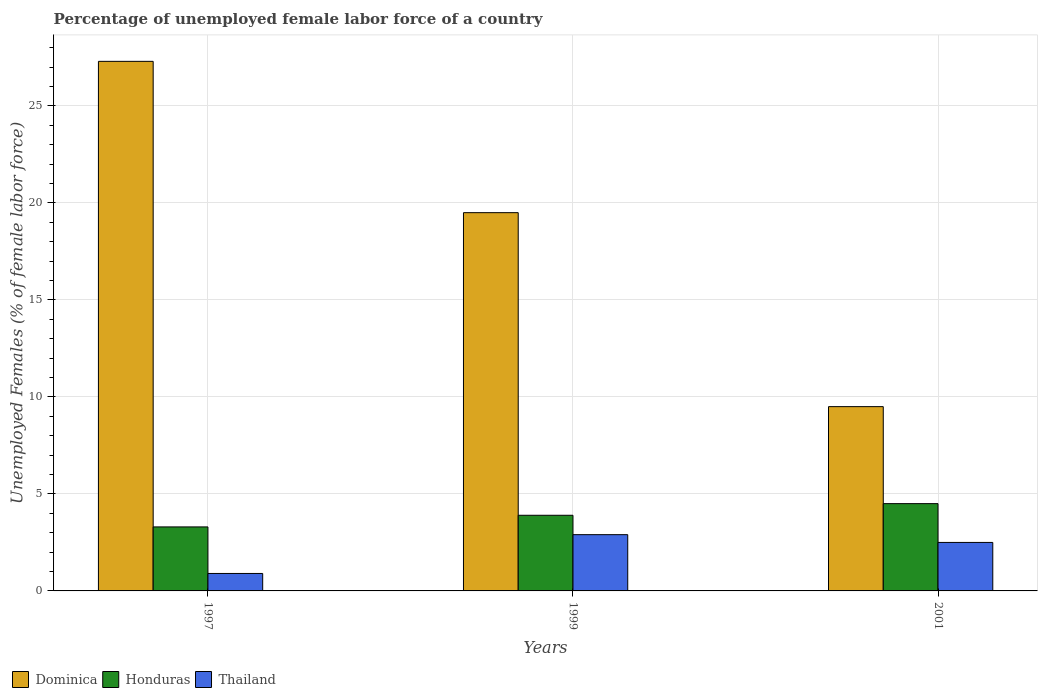How many different coloured bars are there?
Ensure brevity in your answer.  3. Are the number of bars per tick equal to the number of legend labels?
Your response must be concise. Yes. Are the number of bars on each tick of the X-axis equal?
Ensure brevity in your answer.  Yes. How many bars are there on the 3rd tick from the right?
Provide a succinct answer. 3. In how many cases, is the number of bars for a given year not equal to the number of legend labels?
Offer a very short reply. 0. What is the percentage of unemployed female labor force in Dominica in 2001?
Provide a short and direct response. 9.5. Across all years, what is the maximum percentage of unemployed female labor force in Dominica?
Your answer should be compact. 27.3. Across all years, what is the minimum percentage of unemployed female labor force in Honduras?
Your answer should be very brief. 3.3. What is the total percentage of unemployed female labor force in Thailand in the graph?
Provide a succinct answer. 6.3. What is the difference between the percentage of unemployed female labor force in Honduras in 1997 and that in 1999?
Make the answer very short. -0.6. What is the difference between the percentage of unemployed female labor force in Dominica in 1997 and the percentage of unemployed female labor force in Honduras in 2001?
Your answer should be compact. 22.8. What is the average percentage of unemployed female labor force in Dominica per year?
Provide a short and direct response. 18.77. In the year 2001, what is the difference between the percentage of unemployed female labor force in Honduras and percentage of unemployed female labor force in Dominica?
Give a very brief answer. -5. In how many years, is the percentage of unemployed female labor force in Honduras greater than 13 %?
Your response must be concise. 0. What is the ratio of the percentage of unemployed female labor force in Thailand in 1997 to that in 1999?
Keep it short and to the point. 0.31. Is the percentage of unemployed female labor force in Thailand in 1997 less than that in 2001?
Ensure brevity in your answer.  Yes. What is the difference between the highest and the second highest percentage of unemployed female labor force in Thailand?
Provide a short and direct response. 0.4. What is the difference between the highest and the lowest percentage of unemployed female labor force in Dominica?
Make the answer very short. 17.8. What does the 2nd bar from the left in 1997 represents?
Offer a terse response. Honduras. What does the 3rd bar from the right in 1999 represents?
Provide a succinct answer. Dominica. Is it the case that in every year, the sum of the percentage of unemployed female labor force in Honduras and percentage of unemployed female labor force in Thailand is greater than the percentage of unemployed female labor force in Dominica?
Provide a short and direct response. No. How many bars are there?
Give a very brief answer. 9. Are all the bars in the graph horizontal?
Make the answer very short. No. Are the values on the major ticks of Y-axis written in scientific E-notation?
Provide a short and direct response. No. Does the graph contain any zero values?
Ensure brevity in your answer.  No. Where does the legend appear in the graph?
Offer a very short reply. Bottom left. How are the legend labels stacked?
Your answer should be compact. Horizontal. What is the title of the graph?
Your answer should be compact. Percentage of unemployed female labor force of a country. Does "Colombia" appear as one of the legend labels in the graph?
Provide a short and direct response. No. What is the label or title of the X-axis?
Your answer should be very brief. Years. What is the label or title of the Y-axis?
Your response must be concise. Unemployed Females (% of female labor force). What is the Unemployed Females (% of female labor force) in Dominica in 1997?
Your response must be concise. 27.3. What is the Unemployed Females (% of female labor force) in Honduras in 1997?
Your answer should be very brief. 3.3. What is the Unemployed Females (% of female labor force) in Thailand in 1997?
Your answer should be very brief. 0.9. What is the Unemployed Females (% of female labor force) of Honduras in 1999?
Make the answer very short. 3.9. What is the Unemployed Females (% of female labor force) of Thailand in 1999?
Offer a terse response. 2.9. What is the Unemployed Females (% of female labor force) of Honduras in 2001?
Make the answer very short. 4.5. Across all years, what is the maximum Unemployed Females (% of female labor force) in Dominica?
Your answer should be compact. 27.3. Across all years, what is the maximum Unemployed Females (% of female labor force) of Honduras?
Provide a succinct answer. 4.5. Across all years, what is the maximum Unemployed Females (% of female labor force) in Thailand?
Keep it short and to the point. 2.9. Across all years, what is the minimum Unemployed Females (% of female labor force) of Dominica?
Give a very brief answer. 9.5. Across all years, what is the minimum Unemployed Females (% of female labor force) in Honduras?
Ensure brevity in your answer.  3.3. Across all years, what is the minimum Unemployed Females (% of female labor force) in Thailand?
Provide a succinct answer. 0.9. What is the total Unemployed Females (% of female labor force) of Dominica in the graph?
Your answer should be compact. 56.3. What is the difference between the Unemployed Females (% of female labor force) of Dominica in 1997 and that in 1999?
Your answer should be compact. 7.8. What is the difference between the Unemployed Females (% of female labor force) in Honduras in 1997 and that in 1999?
Offer a very short reply. -0.6. What is the difference between the Unemployed Females (% of female labor force) in Thailand in 1997 and that in 1999?
Ensure brevity in your answer.  -2. What is the difference between the Unemployed Females (% of female labor force) of Honduras in 1997 and that in 2001?
Provide a succinct answer. -1.2. What is the difference between the Unemployed Females (% of female labor force) of Thailand in 1997 and that in 2001?
Provide a short and direct response. -1.6. What is the difference between the Unemployed Females (% of female labor force) in Thailand in 1999 and that in 2001?
Your answer should be very brief. 0.4. What is the difference between the Unemployed Females (% of female labor force) in Dominica in 1997 and the Unemployed Females (% of female labor force) in Honduras in 1999?
Make the answer very short. 23.4. What is the difference between the Unemployed Females (% of female labor force) of Dominica in 1997 and the Unemployed Females (% of female labor force) of Thailand in 1999?
Offer a terse response. 24.4. What is the difference between the Unemployed Females (% of female labor force) in Honduras in 1997 and the Unemployed Females (% of female labor force) in Thailand in 1999?
Make the answer very short. 0.4. What is the difference between the Unemployed Females (% of female labor force) of Dominica in 1997 and the Unemployed Females (% of female labor force) of Honduras in 2001?
Give a very brief answer. 22.8. What is the difference between the Unemployed Females (% of female labor force) in Dominica in 1997 and the Unemployed Females (% of female labor force) in Thailand in 2001?
Your answer should be compact. 24.8. What is the difference between the Unemployed Females (% of female labor force) in Dominica in 1999 and the Unemployed Females (% of female labor force) in Honduras in 2001?
Offer a very short reply. 15. What is the difference between the Unemployed Females (% of female labor force) of Dominica in 1999 and the Unemployed Females (% of female labor force) of Thailand in 2001?
Ensure brevity in your answer.  17. What is the average Unemployed Females (% of female labor force) in Dominica per year?
Your answer should be compact. 18.77. What is the average Unemployed Females (% of female labor force) of Honduras per year?
Give a very brief answer. 3.9. What is the average Unemployed Females (% of female labor force) in Thailand per year?
Make the answer very short. 2.1. In the year 1997, what is the difference between the Unemployed Females (% of female labor force) of Dominica and Unemployed Females (% of female labor force) of Thailand?
Provide a short and direct response. 26.4. In the year 1997, what is the difference between the Unemployed Females (% of female labor force) in Honduras and Unemployed Females (% of female labor force) in Thailand?
Your answer should be compact. 2.4. In the year 1999, what is the difference between the Unemployed Females (% of female labor force) of Dominica and Unemployed Females (% of female labor force) of Thailand?
Ensure brevity in your answer.  16.6. In the year 1999, what is the difference between the Unemployed Females (% of female labor force) in Honduras and Unemployed Females (% of female labor force) in Thailand?
Offer a terse response. 1. In the year 2001, what is the difference between the Unemployed Females (% of female labor force) of Dominica and Unemployed Females (% of female labor force) of Thailand?
Ensure brevity in your answer.  7. What is the ratio of the Unemployed Females (% of female labor force) of Honduras in 1997 to that in 1999?
Make the answer very short. 0.85. What is the ratio of the Unemployed Females (% of female labor force) of Thailand in 1997 to that in 1999?
Your response must be concise. 0.31. What is the ratio of the Unemployed Females (% of female labor force) in Dominica in 1997 to that in 2001?
Give a very brief answer. 2.87. What is the ratio of the Unemployed Females (% of female labor force) of Honduras in 1997 to that in 2001?
Give a very brief answer. 0.73. What is the ratio of the Unemployed Females (% of female labor force) in Thailand in 1997 to that in 2001?
Ensure brevity in your answer.  0.36. What is the ratio of the Unemployed Females (% of female labor force) in Dominica in 1999 to that in 2001?
Provide a short and direct response. 2.05. What is the ratio of the Unemployed Females (% of female labor force) of Honduras in 1999 to that in 2001?
Your answer should be compact. 0.87. What is the ratio of the Unemployed Females (% of female labor force) in Thailand in 1999 to that in 2001?
Ensure brevity in your answer.  1.16. What is the difference between the highest and the second highest Unemployed Females (% of female labor force) of Dominica?
Your answer should be compact. 7.8. 